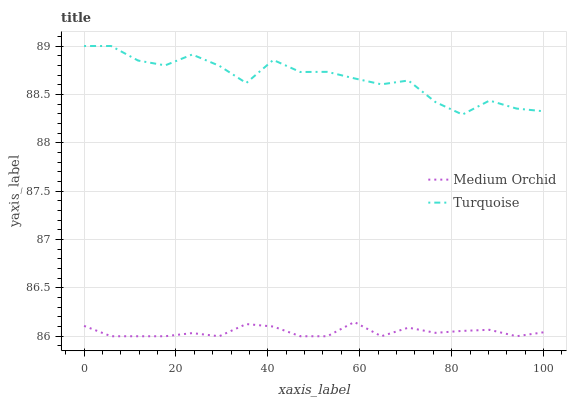Does Medium Orchid have the minimum area under the curve?
Answer yes or no. Yes. Does Turquoise have the maximum area under the curve?
Answer yes or no. Yes. Does Medium Orchid have the maximum area under the curve?
Answer yes or no. No. Is Medium Orchid the smoothest?
Answer yes or no. Yes. Is Turquoise the roughest?
Answer yes or no. Yes. Is Medium Orchid the roughest?
Answer yes or no. No. Does Turquoise have the highest value?
Answer yes or no. Yes. Does Medium Orchid have the highest value?
Answer yes or no. No. Is Medium Orchid less than Turquoise?
Answer yes or no. Yes. Is Turquoise greater than Medium Orchid?
Answer yes or no. Yes. Does Medium Orchid intersect Turquoise?
Answer yes or no. No. 